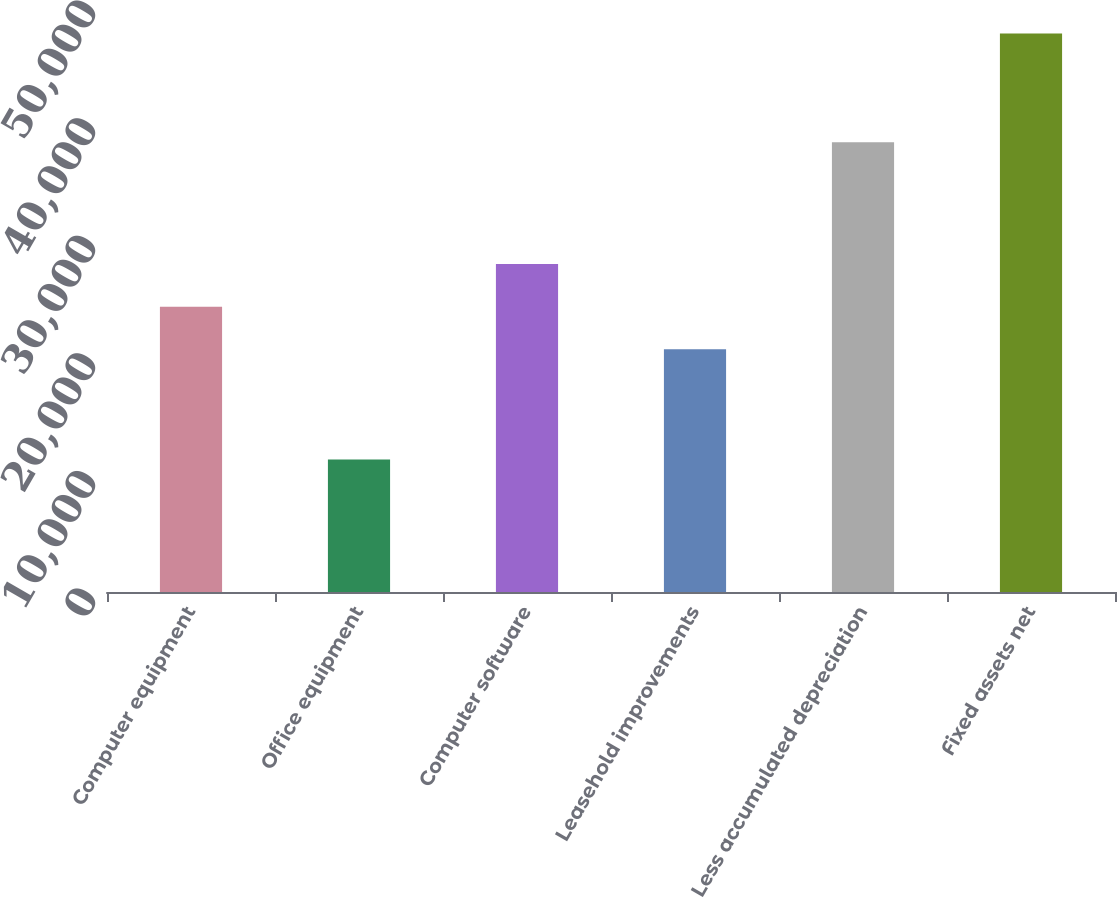Convert chart to OTSL. <chart><loc_0><loc_0><loc_500><loc_500><bar_chart><fcel>Computer equipment<fcel>Office equipment<fcel>Computer software<fcel>Leasehold improvements<fcel>Less accumulated depreciation<fcel>Fixed assets net<nl><fcel>24260.1<fcel>11265<fcel>27883.2<fcel>20637<fcel>38235<fcel>47496<nl></chart> 